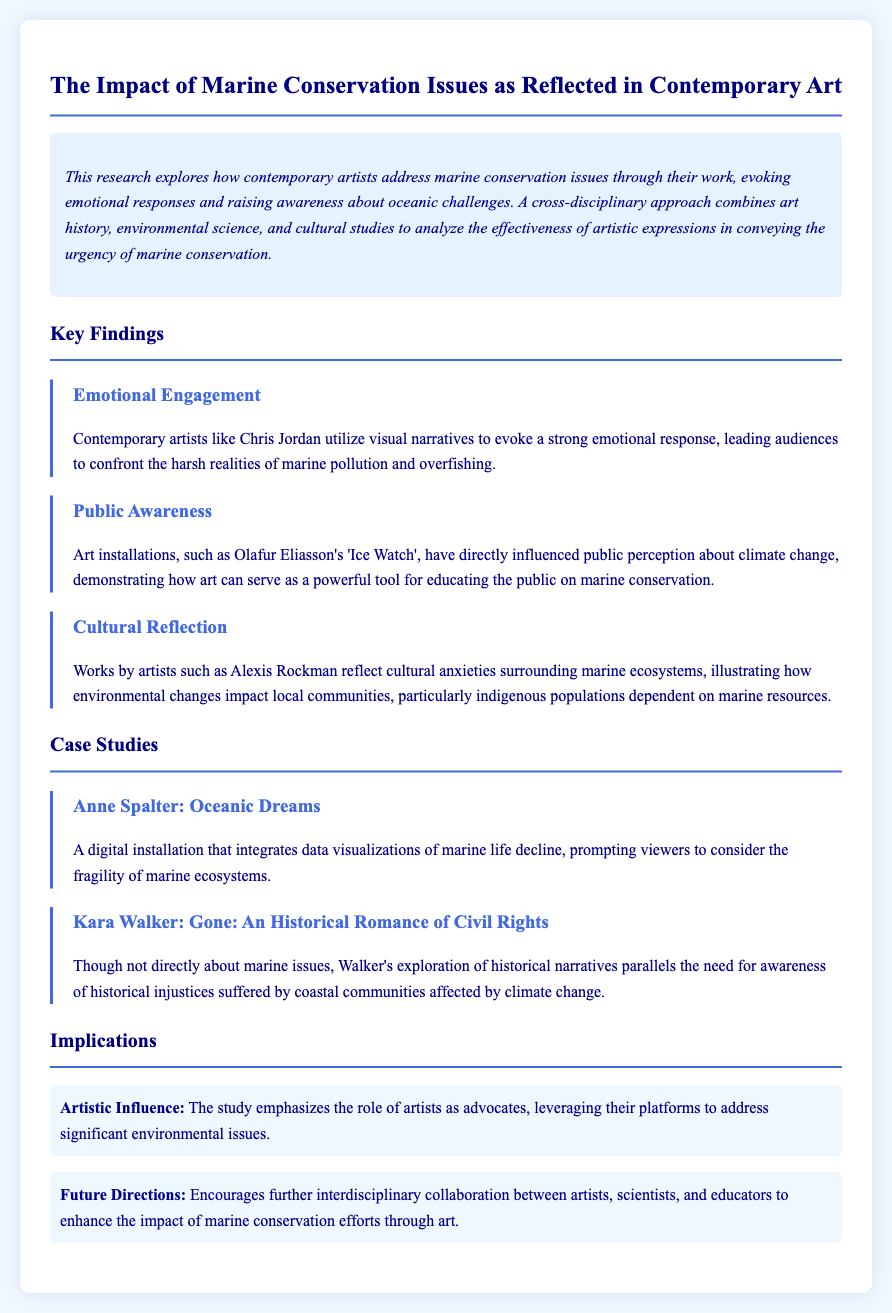What is the title of the research? The title is prominently displayed at the top of the document, specifying the focus of the research.
Answer: The Impact of Marine Conservation Issues as Reflected in Contemporary Art Who is one artist mentioned that evokes strong emotional responses? The document lists contemporary artists and their contributions, highlighting one who effectively engages viewers emotionally.
Answer: Chris Jordan What installation by Olafur Eliasson influences public perception about climate change? Specific artworks are mentioned, with one particularly noted for its public impact on awareness.
Answer: Ice Watch What is one implication of the study? The implications section outlines important insights derived from the research findings regarding the role of artists.
Answer: Artistic Influence What is the name of the case study about a digital installation? The case studies are explicitly titled, showcasing various artists and their works related to marine themes.
Answer: Oceanic Dreams 